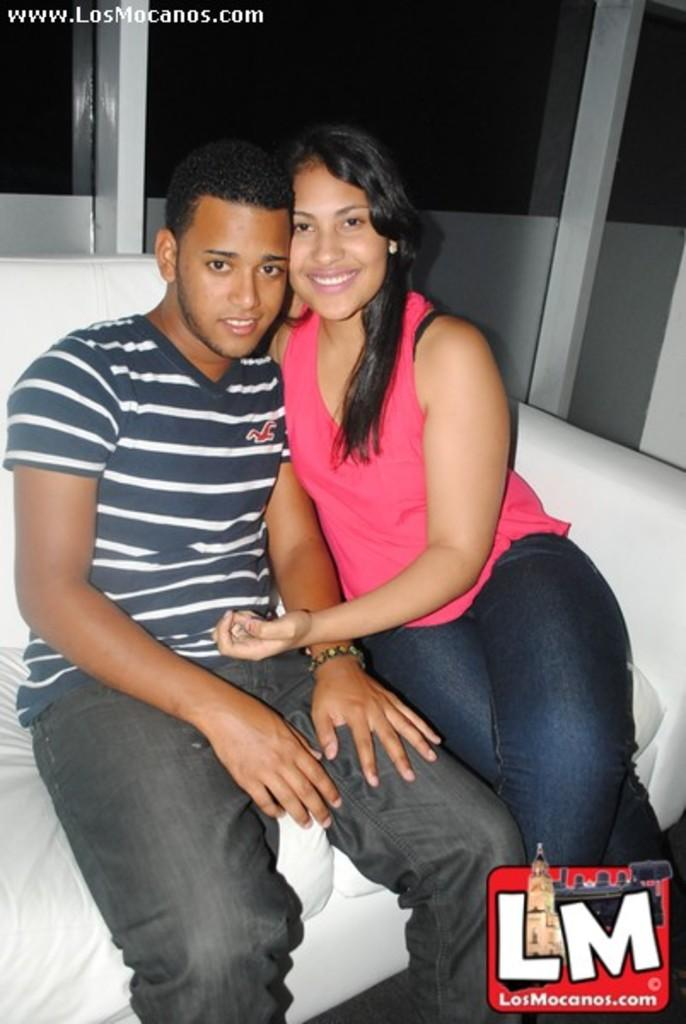Who is present in the image? There is a man and a woman in the image. What are the man and woman doing in the image? Both the man and woman are seated on a sofa. What additional information can be found in the image? There is text in the top left corner of the image and a logo at the bottom. What type of gate is visible in the image? There is no gate present in the image. What is the title of the show that the man and woman are watching in the image? The image does not depict a show, so there is no title to be determined. 